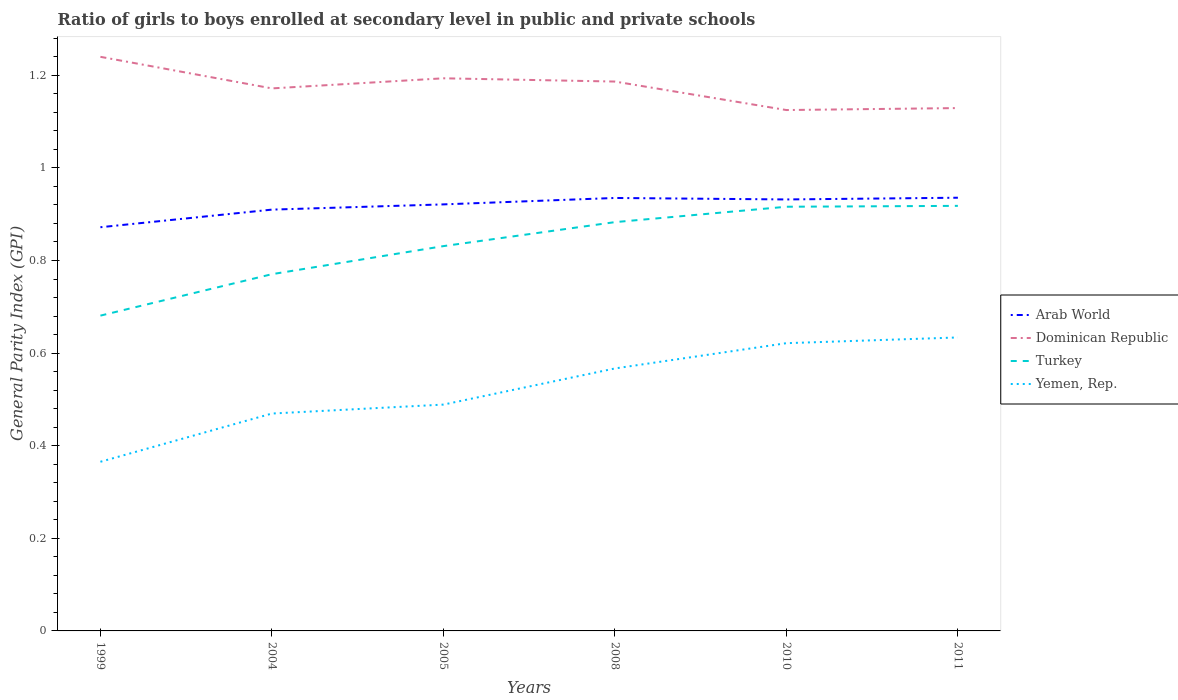How many different coloured lines are there?
Offer a terse response. 4. Across all years, what is the maximum general parity index in Turkey?
Make the answer very short. 0.68. In which year was the general parity index in Turkey maximum?
Ensure brevity in your answer.  1999. What is the total general parity index in Dominican Republic in the graph?
Your answer should be very brief. 0.11. What is the difference between the highest and the second highest general parity index in Dominican Republic?
Ensure brevity in your answer.  0.11. Is the general parity index in Turkey strictly greater than the general parity index in Yemen, Rep. over the years?
Give a very brief answer. No. What is the difference between two consecutive major ticks on the Y-axis?
Keep it short and to the point. 0.2. Does the graph contain any zero values?
Keep it short and to the point. No. Does the graph contain grids?
Your answer should be compact. No. Where does the legend appear in the graph?
Provide a succinct answer. Center right. How many legend labels are there?
Ensure brevity in your answer.  4. What is the title of the graph?
Make the answer very short. Ratio of girls to boys enrolled at secondary level in public and private schools. What is the label or title of the X-axis?
Your answer should be compact. Years. What is the label or title of the Y-axis?
Provide a short and direct response. General Parity Index (GPI). What is the General Parity Index (GPI) of Arab World in 1999?
Offer a terse response. 0.87. What is the General Parity Index (GPI) of Dominican Republic in 1999?
Provide a short and direct response. 1.24. What is the General Parity Index (GPI) in Turkey in 1999?
Offer a terse response. 0.68. What is the General Parity Index (GPI) of Yemen, Rep. in 1999?
Provide a short and direct response. 0.37. What is the General Parity Index (GPI) of Arab World in 2004?
Your response must be concise. 0.91. What is the General Parity Index (GPI) in Dominican Republic in 2004?
Keep it short and to the point. 1.17. What is the General Parity Index (GPI) of Turkey in 2004?
Your answer should be very brief. 0.77. What is the General Parity Index (GPI) of Yemen, Rep. in 2004?
Your answer should be very brief. 0.47. What is the General Parity Index (GPI) of Arab World in 2005?
Provide a short and direct response. 0.92. What is the General Parity Index (GPI) in Dominican Republic in 2005?
Make the answer very short. 1.19. What is the General Parity Index (GPI) in Turkey in 2005?
Your response must be concise. 0.83. What is the General Parity Index (GPI) in Yemen, Rep. in 2005?
Your answer should be compact. 0.49. What is the General Parity Index (GPI) in Arab World in 2008?
Ensure brevity in your answer.  0.94. What is the General Parity Index (GPI) in Dominican Republic in 2008?
Give a very brief answer. 1.19. What is the General Parity Index (GPI) in Turkey in 2008?
Offer a terse response. 0.88. What is the General Parity Index (GPI) in Yemen, Rep. in 2008?
Give a very brief answer. 0.57. What is the General Parity Index (GPI) of Arab World in 2010?
Your response must be concise. 0.93. What is the General Parity Index (GPI) of Dominican Republic in 2010?
Your answer should be very brief. 1.12. What is the General Parity Index (GPI) of Turkey in 2010?
Give a very brief answer. 0.92. What is the General Parity Index (GPI) of Yemen, Rep. in 2010?
Your response must be concise. 0.62. What is the General Parity Index (GPI) of Arab World in 2011?
Offer a terse response. 0.94. What is the General Parity Index (GPI) of Dominican Republic in 2011?
Make the answer very short. 1.13. What is the General Parity Index (GPI) of Turkey in 2011?
Your answer should be very brief. 0.92. What is the General Parity Index (GPI) of Yemen, Rep. in 2011?
Offer a terse response. 0.63. Across all years, what is the maximum General Parity Index (GPI) of Arab World?
Keep it short and to the point. 0.94. Across all years, what is the maximum General Parity Index (GPI) of Dominican Republic?
Your answer should be very brief. 1.24. Across all years, what is the maximum General Parity Index (GPI) in Turkey?
Give a very brief answer. 0.92. Across all years, what is the maximum General Parity Index (GPI) of Yemen, Rep.?
Make the answer very short. 0.63. Across all years, what is the minimum General Parity Index (GPI) of Arab World?
Your response must be concise. 0.87. Across all years, what is the minimum General Parity Index (GPI) of Dominican Republic?
Keep it short and to the point. 1.12. Across all years, what is the minimum General Parity Index (GPI) of Turkey?
Your response must be concise. 0.68. Across all years, what is the minimum General Parity Index (GPI) in Yemen, Rep.?
Offer a very short reply. 0.37. What is the total General Parity Index (GPI) of Arab World in the graph?
Offer a very short reply. 5.51. What is the total General Parity Index (GPI) in Dominican Republic in the graph?
Offer a terse response. 7.05. What is the total General Parity Index (GPI) in Turkey in the graph?
Keep it short and to the point. 5. What is the total General Parity Index (GPI) in Yemen, Rep. in the graph?
Offer a very short reply. 3.15. What is the difference between the General Parity Index (GPI) in Arab World in 1999 and that in 2004?
Provide a succinct answer. -0.04. What is the difference between the General Parity Index (GPI) in Dominican Republic in 1999 and that in 2004?
Provide a short and direct response. 0.07. What is the difference between the General Parity Index (GPI) in Turkey in 1999 and that in 2004?
Provide a short and direct response. -0.09. What is the difference between the General Parity Index (GPI) in Yemen, Rep. in 1999 and that in 2004?
Your response must be concise. -0.1. What is the difference between the General Parity Index (GPI) in Arab World in 1999 and that in 2005?
Provide a short and direct response. -0.05. What is the difference between the General Parity Index (GPI) of Dominican Republic in 1999 and that in 2005?
Your answer should be compact. 0.05. What is the difference between the General Parity Index (GPI) in Turkey in 1999 and that in 2005?
Your answer should be compact. -0.15. What is the difference between the General Parity Index (GPI) in Yemen, Rep. in 1999 and that in 2005?
Your response must be concise. -0.12. What is the difference between the General Parity Index (GPI) in Arab World in 1999 and that in 2008?
Keep it short and to the point. -0.06. What is the difference between the General Parity Index (GPI) of Dominican Republic in 1999 and that in 2008?
Your answer should be very brief. 0.05. What is the difference between the General Parity Index (GPI) in Turkey in 1999 and that in 2008?
Ensure brevity in your answer.  -0.2. What is the difference between the General Parity Index (GPI) of Yemen, Rep. in 1999 and that in 2008?
Ensure brevity in your answer.  -0.2. What is the difference between the General Parity Index (GPI) of Arab World in 1999 and that in 2010?
Keep it short and to the point. -0.06. What is the difference between the General Parity Index (GPI) in Dominican Republic in 1999 and that in 2010?
Give a very brief answer. 0.11. What is the difference between the General Parity Index (GPI) in Turkey in 1999 and that in 2010?
Provide a succinct answer. -0.24. What is the difference between the General Parity Index (GPI) in Yemen, Rep. in 1999 and that in 2010?
Your answer should be very brief. -0.26. What is the difference between the General Parity Index (GPI) of Arab World in 1999 and that in 2011?
Keep it short and to the point. -0.06. What is the difference between the General Parity Index (GPI) in Dominican Republic in 1999 and that in 2011?
Provide a short and direct response. 0.11. What is the difference between the General Parity Index (GPI) in Turkey in 1999 and that in 2011?
Keep it short and to the point. -0.24. What is the difference between the General Parity Index (GPI) in Yemen, Rep. in 1999 and that in 2011?
Ensure brevity in your answer.  -0.27. What is the difference between the General Parity Index (GPI) in Arab World in 2004 and that in 2005?
Keep it short and to the point. -0.01. What is the difference between the General Parity Index (GPI) in Dominican Republic in 2004 and that in 2005?
Make the answer very short. -0.02. What is the difference between the General Parity Index (GPI) in Turkey in 2004 and that in 2005?
Make the answer very short. -0.06. What is the difference between the General Parity Index (GPI) in Yemen, Rep. in 2004 and that in 2005?
Make the answer very short. -0.02. What is the difference between the General Parity Index (GPI) in Arab World in 2004 and that in 2008?
Provide a succinct answer. -0.03. What is the difference between the General Parity Index (GPI) in Dominican Republic in 2004 and that in 2008?
Ensure brevity in your answer.  -0.01. What is the difference between the General Parity Index (GPI) of Turkey in 2004 and that in 2008?
Give a very brief answer. -0.11. What is the difference between the General Parity Index (GPI) in Yemen, Rep. in 2004 and that in 2008?
Your response must be concise. -0.1. What is the difference between the General Parity Index (GPI) in Arab World in 2004 and that in 2010?
Your answer should be compact. -0.02. What is the difference between the General Parity Index (GPI) in Dominican Republic in 2004 and that in 2010?
Provide a succinct answer. 0.05. What is the difference between the General Parity Index (GPI) of Turkey in 2004 and that in 2010?
Provide a succinct answer. -0.15. What is the difference between the General Parity Index (GPI) of Yemen, Rep. in 2004 and that in 2010?
Offer a terse response. -0.15. What is the difference between the General Parity Index (GPI) of Arab World in 2004 and that in 2011?
Your answer should be compact. -0.03. What is the difference between the General Parity Index (GPI) of Dominican Republic in 2004 and that in 2011?
Provide a short and direct response. 0.04. What is the difference between the General Parity Index (GPI) of Turkey in 2004 and that in 2011?
Make the answer very short. -0.15. What is the difference between the General Parity Index (GPI) of Yemen, Rep. in 2004 and that in 2011?
Give a very brief answer. -0.16. What is the difference between the General Parity Index (GPI) of Arab World in 2005 and that in 2008?
Your answer should be very brief. -0.01. What is the difference between the General Parity Index (GPI) in Dominican Republic in 2005 and that in 2008?
Offer a very short reply. 0.01. What is the difference between the General Parity Index (GPI) of Turkey in 2005 and that in 2008?
Offer a very short reply. -0.05. What is the difference between the General Parity Index (GPI) of Yemen, Rep. in 2005 and that in 2008?
Your answer should be very brief. -0.08. What is the difference between the General Parity Index (GPI) in Arab World in 2005 and that in 2010?
Give a very brief answer. -0.01. What is the difference between the General Parity Index (GPI) of Dominican Republic in 2005 and that in 2010?
Make the answer very short. 0.07. What is the difference between the General Parity Index (GPI) of Turkey in 2005 and that in 2010?
Keep it short and to the point. -0.09. What is the difference between the General Parity Index (GPI) in Yemen, Rep. in 2005 and that in 2010?
Give a very brief answer. -0.13. What is the difference between the General Parity Index (GPI) of Arab World in 2005 and that in 2011?
Offer a very short reply. -0.01. What is the difference between the General Parity Index (GPI) of Dominican Republic in 2005 and that in 2011?
Keep it short and to the point. 0.06. What is the difference between the General Parity Index (GPI) in Turkey in 2005 and that in 2011?
Provide a short and direct response. -0.09. What is the difference between the General Parity Index (GPI) in Yemen, Rep. in 2005 and that in 2011?
Offer a very short reply. -0.14. What is the difference between the General Parity Index (GPI) in Arab World in 2008 and that in 2010?
Your answer should be very brief. 0. What is the difference between the General Parity Index (GPI) of Dominican Republic in 2008 and that in 2010?
Your answer should be very brief. 0.06. What is the difference between the General Parity Index (GPI) in Turkey in 2008 and that in 2010?
Your response must be concise. -0.03. What is the difference between the General Parity Index (GPI) of Yemen, Rep. in 2008 and that in 2010?
Your response must be concise. -0.05. What is the difference between the General Parity Index (GPI) in Arab World in 2008 and that in 2011?
Your answer should be compact. -0. What is the difference between the General Parity Index (GPI) of Dominican Republic in 2008 and that in 2011?
Your answer should be very brief. 0.06. What is the difference between the General Parity Index (GPI) of Turkey in 2008 and that in 2011?
Your answer should be compact. -0.04. What is the difference between the General Parity Index (GPI) in Yemen, Rep. in 2008 and that in 2011?
Ensure brevity in your answer.  -0.07. What is the difference between the General Parity Index (GPI) in Arab World in 2010 and that in 2011?
Your response must be concise. -0. What is the difference between the General Parity Index (GPI) of Dominican Republic in 2010 and that in 2011?
Provide a succinct answer. -0. What is the difference between the General Parity Index (GPI) in Turkey in 2010 and that in 2011?
Ensure brevity in your answer.  -0. What is the difference between the General Parity Index (GPI) of Yemen, Rep. in 2010 and that in 2011?
Provide a succinct answer. -0.01. What is the difference between the General Parity Index (GPI) in Arab World in 1999 and the General Parity Index (GPI) in Dominican Republic in 2004?
Your answer should be very brief. -0.3. What is the difference between the General Parity Index (GPI) in Arab World in 1999 and the General Parity Index (GPI) in Turkey in 2004?
Offer a very short reply. 0.1. What is the difference between the General Parity Index (GPI) in Arab World in 1999 and the General Parity Index (GPI) in Yemen, Rep. in 2004?
Provide a succinct answer. 0.4. What is the difference between the General Parity Index (GPI) in Dominican Republic in 1999 and the General Parity Index (GPI) in Turkey in 2004?
Provide a short and direct response. 0.47. What is the difference between the General Parity Index (GPI) of Dominican Republic in 1999 and the General Parity Index (GPI) of Yemen, Rep. in 2004?
Ensure brevity in your answer.  0.77. What is the difference between the General Parity Index (GPI) in Turkey in 1999 and the General Parity Index (GPI) in Yemen, Rep. in 2004?
Your answer should be very brief. 0.21. What is the difference between the General Parity Index (GPI) in Arab World in 1999 and the General Parity Index (GPI) in Dominican Republic in 2005?
Provide a succinct answer. -0.32. What is the difference between the General Parity Index (GPI) of Arab World in 1999 and the General Parity Index (GPI) of Turkey in 2005?
Offer a terse response. 0.04. What is the difference between the General Parity Index (GPI) in Arab World in 1999 and the General Parity Index (GPI) in Yemen, Rep. in 2005?
Your answer should be very brief. 0.38. What is the difference between the General Parity Index (GPI) of Dominican Republic in 1999 and the General Parity Index (GPI) of Turkey in 2005?
Give a very brief answer. 0.41. What is the difference between the General Parity Index (GPI) of Dominican Republic in 1999 and the General Parity Index (GPI) of Yemen, Rep. in 2005?
Keep it short and to the point. 0.75. What is the difference between the General Parity Index (GPI) of Turkey in 1999 and the General Parity Index (GPI) of Yemen, Rep. in 2005?
Offer a very short reply. 0.19. What is the difference between the General Parity Index (GPI) in Arab World in 1999 and the General Parity Index (GPI) in Dominican Republic in 2008?
Your answer should be very brief. -0.31. What is the difference between the General Parity Index (GPI) in Arab World in 1999 and the General Parity Index (GPI) in Turkey in 2008?
Give a very brief answer. -0.01. What is the difference between the General Parity Index (GPI) in Arab World in 1999 and the General Parity Index (GPI) in Yemen, Rep. in 2008?
Offer a very short reply. 0.3. What is the difference between the General Parity Index (GPI) in Dominican Republic in 1999 and the General Parity Index (GPI) in Turkey in 2008?
Offer a very short reply. 0.36. What is the difference between the General Parity Index (GPI) of Dominican Republic in 1999 and the General Parity Index (GPI) of Yemen, Rep. in 2008?
Keep it short and to the point. 0.67. What is the difference between the General Parity Index (GPI) in Turkey in 1999 and the General Parity Index (GPI) in Yemen, Rep. in 2008?
Give a very brief answer. 0.11. What is the difference between the General Parity Index (GPI) in Arab World in 1999 and the General Parity Index (GPI) in Dominican Republic in 2010?
Make the answer very short. -0.25. What is the difference between the General Parity Index (GPI) of Arab World in 1999 and the General Parity Index (GPI) of Turkey in 2010?
Your response must be concise. -0.04. What is the difference between the General Parity Index (GPI) in Arab World in 1999 and the General Parity Index (GPI) in Yemen, Rep. in 2010?
Provide a succinct answer. 0.25. What is the difference between the General Parity Index (GPI) in Dominican Republic in 1999 and the General Parity Index (GPI) in Turkey in 2010?
Offer a terse response. 0.32. What is the difference between the General Parity Index (GPI) in Dominican Republic in 1999 and the General Parity Index (GPI) in Yemen, Rep. in 2010?
Your answer should be compact. 0.62. What is the difference between the General Parity Index (GPI) of Turkey in 1999 and the General Parity Index (GPI) of Yemen, Rep. in 2010?
Offer a very short reply. 0.06. What is the difference between the General Parity Index (GPI) in Arab World in 1999 and the General Parity Index (GPI) in Dominican Republic in 2011?
Keep it short and to the point. -0.26. What is the difference between the General Parity Index (GPI) in Arab World in 1999 and the General Parity Index (GPI) in Turkey in 2011?
Ensure brevity in your answer.  -0.05. What is the difference between the General Parity Index (GPI) of Arab World in 1999 and the General Parity Index (GPI) of Yemen, Rep. in 2011?
Your response must be concise. 0.24. What is the difference between the General Parity Index (GPI) in Dominican Republic in 1999 and the General Parity Index (GPI) in Turkey in 2011?
Ensure brevity in your answer.  0.32. What is the difference between the General Parity Index (GPI) in Dominican Republic in 1999 and the General Parity Index (GPI) in Yemen, Rep. in 2011?
Provide a succinct answer. 0.61. What is the difference between the General Parity Index (GPI) of Turkey in 1999 and the General Parity Index (GPI) of Yemen, Rep. in 2011?
Provide a short and direct response. 0.05. What is the difference between the General Parity Index (GPI) in Arab World in 2004 and the General Parity Index (GPI) in Dominican Republic in 2005?
Offer a terse response. -0.28. What is the difference between the General Parity Index (GPI) of Arab World in 2004 and the General Parity Index (GPI) of Turkey in 2005?
Your response must be concise. 0.08. What is the difference between the General Parity Index (GPI) of Arab World in 2004 and the General Parity Index (GPI) of Yemen, Rep. in 2005?
Provide a succinct answer. 0.42. What is the difference between the General Parity Index (GPI) in Dominican Republic in 2004 and the General Parity Index (GPI) in Turkey in 2005?
Offer a terse response. 0.34. What is the difference between the General Parity Index (GPI) in Dominican Republic in 2004 and the General Parity Index (GPI) in Yemen, Rep. in 2005?
Keep it short and to the point. 0.68. What is the difference between the General Parity Index (GPI) of Turkey in 2004 and the General Parity Index (GPI) of Yemen, Rep. in 2005?
Keep it short and to the point. 0.28. What is the difference between the General Parity Index (GPI) in Arab World in 2004 and the General Parity Index (GPI) in Dominican Republic in 2008?
Make the answer very short. -0.28. What is the difference between the General Parity Index (GPI) in Arab World in 2004 and the General Parity Index (GPI) in Turkey in 2008?
Give a very brief answer. 0.03. What is the difference between the General Parity Index (GPI) of Arab World in 2004 and the General Parity Index (GPI) of Yemen, Rep. in 2008?
Ensure brevity in your answer.  0.34. What is the difference between the General Parity Index (GPI) of Dominican Republic in 2004 and the General Parity Index (GPI) of Turkey in 2008?
Offer a terse response. 0.29. What is the difference between the General Parity Index (GPI) in Dominican Republic in 2004 and the General Parity Index (GPI) in Yemen, Rep. in 2008?
Your response must be concise. 0.6. What is the difference between the General Parity Index (GPI) in Turkey in 2004 and the General Parity Index (GPI) in Yemen, Rep. in 2008?
Ensure brevity in your answer.  0.2. What is the difference between the General Parity Index (GPI) of Arab World in 2004 and the General Parity Index (GPI) of Dominican Republic in 2010?
Give a very brief answer. -0.22. What is the difference between the General Parity Index (GPI) in Arab World in 2004 and the General Parity Index (GPI) in Turkey in 2010?
Offer a terse response. -0.01. What is the difference between the General Parity Index (GPI) of Arab World in 2004 and the General Parity Index (GPI) of Yemen, Rep. in 2010?
Offer a terse response. 0.29. What is the difference between the General Parity Index (GPI) of Dominican Republic in 2004 and the General Parity Index (GPI) of Turkey in 2010?
Ensure brevity in your answer.  0.26. What is the difference between the General Parity Index (GPI) in Dominican Republic in 2004 and the General Parity Index (GPI) in Yemen, Rep. in 2010?
Offer a very short reply. 0.55. What is the difference between the General Parity Index (GPI) in Turkey in 2004 and the General Parity Index (GPI) in Yemen, Rep. in 2010?
Provide a short and direct response. 0.15. What is the difference between the General Parity Index (GPI) of Arab World in 2004 and the General Parity Index (GPI) of Dominican Republic in 2011?
Provide a short and direct response. -0.22. What is the difference between the General Parity Index (GPI) in Arab World in 2004 and the General Parity Index (GPI) in Turkey in 2011?
Give a very brief answer. -0.01. What is the difference between the General Parity Index (GPI) of Arab World in 2004 and the General Parity Index (GPI) of Yemen, Rep. in 2011?
Keep it short and to the point. 0.28. What is the difference between the General Parity Index (GPI) of Dominican Republic in 2004 and the General Parity Index (GPI) of Turkey in 2011?
Keep it short and to the point. 0.25. What is the difference between the General Parity Index (GPI) in Dominican Republic in 2004 and the General Parity Index (GPI) in Yemen, Rep. in 2011?
Offer a terse response. 0.54. What is the difference between the General Parity Index (GPI) in Turkey in 2004 and the General Parity Index (GPI) in Yemen, Rep. in 2011?
Offer a very short reply. 0.14. What is the difference between the General Parity Index (GPI) of Arab World in 2005 and the General Parity Index (GPI) of Dominican Republic in 2008?
Keep it short and to the point. -0.27. What is the difference between the General Parity Index (GPI) in Arab World in 2005 and the General Parity Index (GPI) in Turkey in 2008?
Make the answer very short. 0.04. What is the difference between the General Parity Index (GPI) of Arab World in 2005 and the General Parity Index (GPI) of Yemen, Rep. in 2008?
Your answer should be compact. 0.35. What is the difference between the General Parity Index (GPI) of Dominican Republic in 2005 and the General Parity Index (GPI) of Turkey in 2008?
Keep it short and to the point. 0.31. What is the difference between the General Parity Index (GPI) of Dominican Republic in 2005 and the General Parity Index (GPI) of Yemen, Rep. in 2008?
Provide a short and direct response. 0.63. What is the difference between the General Parity Index (GPI) of Turkey in 2005 and the General Parity Index (GPI) of Yemen, Rep. in 2008?
Offer a terse response. 0.26. What is the difference between the General Parity Index (GPI) of Arab World in 2005 and the General Parity Index (GPI) of Dominican Republic in 2010?
Offer a very short reply. -0.2. What is the difference between the General Parity Index (GPI) of Arab World in 2005 and the General Parity Index (GPI) of Turkey in 2010?
Your answer should be very brief. 0.01. What is the difference between the General Parity Index (GPI) of Arab World in 2005 and the General Parity Index (GPI) of Yemen, Rep. in 2010?
Your response must be concise. 0.3. What is the difference between the General Parity Index (GPI) in Dominican Republic in 2005 and the General Parity Index (GPI) in Turkey in 2010?
Give a very brief answer. 0.28. What is the difference between the General Parity Index (GPI) in Dominican Republic in 2005 and the General Parity Index (GPI) in Yemen, Rep. in 2010?
Your answer should be compact. 0.57. What is the difference between the General Parity Index (GPI) of Turkey in 2005 and the General Parity Index (GPI) of Yemen, Rep. in 2010?
Provide a short and direct response. 0.21. What is the difference between the General Parity Index (GPI) of Arab World in 2005 and the General Parity Index (GPI) of Dominican Republic in 2011?
Your answer should be very brief. -0.21. What is the difference between the General Parity Index (GPI) of Arab World in 2005 and the General Parity Index (GPI) of Turkey in 2011?
Provide a short and direct response. 0. What is the difference between the General Parity Index (GPI) in Arab World in 2005 and the General Parity Index (GPI) in Yemen, Rep. in 2011?
Your answer should be very brief. 0.29. What is the difference between the General Parity Index (GPI) of Dominican Republic in 2005 and the General Parity Index (GPI) of Turkey in 2011?
Give a very brief answer. 0.28. What is the difference between the General Parity Index (GPI) in Dominican Republic in 2005 and the General Parity Index (GPI) in Yemen, Rep. in 2011?
Offer a terse response. 0.56. What is the difference between the General Parity Index (GPI) of Turkey in 2005 and the General Parity Index (GPI) of Yemen, Rep. in 2011?
Your answer should be very brief. 0.2. What is the difference between the General Parity Index (GPI) in Arab World in 2008 and the General Parity Index (GPI) in Dominican Republic in 2010?
Keep it short and to the point. -0.19. What is the difference between the General Parity Index (GPI) of Arab World in 2008 and the General Parity Index (GPI) of Turkey in 2010?
Your response must be concise. 0.02. What is the difference between the General Parity Index (GPI) in Arab World in 2008 and the General Parity Index (GPI) in Yemen, Rep. in 2010?
Make the answer very short. 0.31. What is the difference between the General Parity Index (GPI) of Dominican Republic in 2008 and the General Parity Index (GPI) of Turkey in 2010?
Give a very brief answer. 0.27. What is the difference between the General Parity Index (GPI) of Dominican Republic in 2008 and the General Parity Index (GPI) of Yemen, Rep. in 2010?
Offer a very short reply. 0.56. What is the difference between the General Parity Index (GPI) in Turkey in 2008 and the General Parity Index (GPI) in Yemen, Rep. in 2010?
Ensure brevity in your answer.  0.26. What is the difference between the General Parity Index (GPI) in Arab World in 2008 and the General Parity Index (GPI) in Dominican Republic in 2011?
Ensure brevity in your answer.  -0.19. What is the difference between the General Parity Index (GPI) in Arab World in 2008 and the General Parity Index (GPI) in Turkey in 2011?
Make the answer very short. 0.02. What is the difference between the General Parity Index (GPI) in Arab World in 2008 and the General Parity Index (GPI) in Yemen, Rep. in 2011?
Your answer should be compact. 0.3. What is the difference between the General Parity Index (GPI) in Dominican Republic in 2008 and the General Parity Index (GPI) in Turkey in 2011?
Your answer should be compact. 0.27. What is the difference between the General Parity Index (GPI) of Dominican Republic in 2008 and the General Parity Index (GPI) of Yemen, Rep. in 2011?
Provide a succinct answer. 0.55. What is the difference between the General Parity Index (GPI) of Turkey in 2008 and the General Parity Index (GPI) of Yemen, Rep. in 2011?
Provide a short and direct response. 0.25. What is the difference between the General Parity Index (GPI) in Arab World in 2010 and the General Parity Index (GPI) in Dominican Republic in 2011?
Provide a succinct answer. -0.2. What is the difference between the General Parity Index (GPI) in Arab World in 2010 and the General Parity Index (GPI) in Turkey in 2011?
Your answer should be compact. 0.01. What is the difference between the General Parity Index (GPI) of Arab World in 2010 and the General Parity Index (GPI) of Yemen, Rep. in 2011?
Give a very brief answer. 0.3. What is the difference between the General Parity Index (GPI) in Dominican Republic in 2010 and the General Parity Index (GPI) in Turkey in 2011?
Provide a succinct answer. 0.21. What is the difference between the General Parity Index (GPI) in Dominican Republic in 2010 and the General Parity Index (GPI) in Yemen, Rep. in 2011?
Ensure brevity in your answer.  0.49. What is the difference between the General Parity Index (GPI) in Turkey in 2010 and the General Parity Index (GPI) in Yemen, Rep. in 2011?
Your response must be concise. 0.28. What is the average General Parity Index (GPI) of Arab World per year?
Offer a terse response. 0.92. What is the average General Parity Index (GPI) in Dominican Republic per year?
Provide a short and direct response. 1.17. What is the average General Parity Index (GPI) in Turkey per year?
Your answer should be compact. 0.83. What is the average General Parity Index (GPI) of Yemen, Rep. per year?
Make the answer very short. 0.52. In the year 1999, what is the difference between the General Parity Index (GPI) in Arab World and General Parity Index (GPI) in Dominican Republic?
Ensure brevity in your answer.  -0.37. In the year 1999, what is the difference between the General Parity Index (GPI) of Arab World and General Parity Index (GPI) of Turkey?
Give a very brief answer. 0.19. In the year 1999, what is the difference between the General Parity Index (GPI) of Arab World and General Parity Index (GPI) of Yemen, Rep.?
Keep it short and to the point. 0.51. In the year 1999, what is the difference between the General Parity Index (GPI) in Dominican Republic and General Parity Index (GPI) in Turkey?
Provide a short and direct response. 0.56. In the year 1999, what is the difference between the General Parity Index (GPI) in Dominican Republic and General Parity Index (GPI) in Yemen, Rep.?
Give a very brief answer. 0.87. In the year 1999, what is the difference between the General Parity Index (GPI) of Turkey and General Parity Index (GPI) of Yemen, Rep.?
Your response must be concise. 0.32. In the year 2004, what is the difference between the General Parity Index (GPI) of Arab World and General Parity Index (GPI) of Dominican Republic?
Provide a short and direct response. -0.26. In the year 2004, what is the difference between the General Parity Index (GPI) of Arab World and General Parity Index (GPI) of Turkey?
Your answer should be compact. 0.14. In the year 2004, what is the difference between the General Parity Index (GPI) in Arab World and General Parity Index (GPI) in Yemen, Rep.?
Make the answer very short. 0.44. In the year 2004, what is the difference between the General Parity Index (GPI) in Dominican Republic and General Parity Index (GPI) in Turkey?
Your answer should be very brief. 0.4. In the year 2004, what is the difference between the General Parity Index (GPI) of Dominican Republic and General Parity Index (GPI) of Yemen, Rep.?
Your answer should be very brief. 0.7. In the year 2004, what is the difference between the General Parity Index (GPI) of Turkey and General Parity Index (GPI) of Yemen, Rep.?
Offer a very short reply. 0.3. In the year 2005, what is the difference between the General Parity Index (GPI) in Arab World and General Parity Index (GPI) in Dominican Republic?
Ensure brevity in your answer.  -0.27. In the year 2005, what is the difference between the General Parity Index (GPI) in Arab World and General Parity Index (GPI) in Turkey?
Your answer should be compact. 0.09. In the year 2005, what is the difference between the General Parity Index (GPI) in Arab World and General Parity Index (GPI) in Yemen, Rep.?
Provide a short and direct response. 0.43. In the year 2005, what is the difference between the General Parity Index (GPI) in Dominican Republic and General Parity Index (GPI) in Turkey?
Offer a very short reply. 0.36. In the year 2005, what is the difference between the General Parity Index (GPI) in Dominican Republic and General Parity Index (GPI) in Yemen, Rep.?
Make the answer very short. 0.7. In the year 2005, what is the difference between the General Parity Index (GPI) of Turkey and General Parity Index (GPI) of Yemen, Rep.?
Give a very brief answer. 0.34. In the year 2008, what is the difference between the General Parity Index (GPI) in Arab World and General Parity Index (GPI) in Dominican Republic?
Offer a very short reply. -0.25. In the year 2008, what is the difference between the General Parity Index (GPI) in Arab World and General Parity Index (GPI) in Turkey?
Your answer should be very brief. 0.05. In the year 2008, what is the difference between the General Parity Index (GPI) in Arab World and General Parity Index (GPI) in Yemen, Rep.?
Your response must be concise. 0.37. In the year 2008, what is the difference between the General Parity Index (GPI) of Dominican Republic and General Parity Index (GPI) of Turkey?
Offer a terse response. 0.3. In the year 2008, what is the difference between the General Parity Index (GPI) in Dominican Republic and General Parity Index (GPI) in Yemen, Rep.?
Your answer should be compact. 0.62. In the year 2008, what is the difference between the General Parity Index (GPI) in Turkey and General Parity Index (GPI) in Yemen, Rep.?
Provide a short and direct response. 0.32. In the year 2010, what is the difference between the General Parity Index (GPI) in Arab World and General Parity Index (GPI) in Dominican Republic?
Provide a succinct answer. -0.19. In the year 2010, what is the difference between the General Parity Index (GPI) in Arab World and General Parity Index (GPI) in Turkey?
Your answer should be very brief. 0.02. In the year 2010, what is the difference between the General Parity Index (GPI) of Arab World and General Parity Index (GPI) of Yemen, Rep.?
Provide a short and direct response. 0.31. In the year 2010, what is the difference between the General Parity Index (GPI) in Dominican Republic and General Parity Index (GPI) in Turkey?
Your answer should be very brief. 0.21. In the year 2010, what is the difference between the General Parity Index (GPI) in Dominican Republic and General Parity Index (GPI) in Yemen, Rep.?
Your answer should be very brief. 0.5. In the year 2010, what is the difference between the General Parity Index (GPI) in Turkey and General Parity Index (GPI) in Yemen, Rep.?
Offer a terse response. 0.29. In the year 2011, what is the difference between the General Parity Index (GPI) of Arab World and General Parity Index (GPI) of Dominican Republic?
Keep it short and to the point. -0.19. In the year 2011, what is the difference between the General Parity Index (GPI) in Arab World and General Parity Index (GPI) in Turkey?
Offer a very short reply. 0.02. In the year 2011, what is the difference between the General Parity Index (GPI) of Arab World and General Parity Index (GPI) of Yemen, Rep.?
Your answer should be compact. 0.3. In the year 2011, what is the difference between the General Parity Index (GPI) in Dominican Republic and General Parity Index (GPI) in Turkey?
Ensure brevity in your answer.  0.21. In the year 2011, what is the difference between the General Parity Index (GPI) in Dominican Republic and General Parity Index (GPI) in Yemen, Rep.?
Offer a terse response. 0.5. In the year 2011, what is the difference between the General Parity Index (GPI) of Turkey and General Parity Index (GPI) of Yemen, Rep.?
Offer a terse response. 0.28. What is the ratio of the General Parity Index (GPI) of Arab World in 1999 to that in 2004?
Your answer should be very brief. 0.96. What is the ratio of the General Parity Index (GPI) in Dominican Republic in 1999 to that in 2004?
Keep it short and to the point. 1.06. What is the ratio of the General Parity Index (GPI) in Turkey in 1999 to that in 2004?
Your answer should be very brief. 0.88. What is the ratio of the General Parity Index (GPI) of Yemen, Rep. in 1999 to that in 2004?
Ensure brevity in your answer.  0.78. What is the ratio of the General Parity Index (GPI) of Arab World in 1999 to that in 2005?
Offer a very short reply. 0.95. What is the ratio of the General Parity Index (GPI) of Dominican Republic in 1999 to that in 2005?
Offer a very short reply. 1.04. What is the ratio of the General Parity Index (GPI) in Turkey in 1999 to that in 2005?
Offer a terse response. 0.82. What is the ratio of the General Parity Index (GPI) of Yemen, Rep. in 1999 to that in 2005?
Ensure brevity in your answer.  0.75. What is the ratio of the General Parity Index (GPI) of Arab World in 1999 to that in 2008?
Ensure brevity in your answer.  0.93. What is the ratio of the General Parity Index (GPI) in Dominican Republic in 1999 to that in 2008?
Provide a succinct answer. 1.04. What is the ratio of the General Parity Index (GPI) of Turkey in 1999 to that in 2008?
Keep it short and to the point. 0.77. What is the ratio of the General Parity Index (GPI) in Yemen, Rep. in 1999 to that in 2008?
Provide a short and direct response. 0.64. What is the ratio of the General Parity Index (GPI) of Arab World in 1999 to that in 2010?
Offer a terse response. 0.94. What is the ratio of the General Parity Index (GPI) in Dominican Republic in 1999 to that in 2010?
Ensure brevity in your answer.  1.1. What is the ratio of the General Parity Index (GPI) of Turkey in 1999 to that in 2010?
Offer a very short reply. 0.74. What is the ratio of the General Parity Index (GPI) of Yemen, Rep. in 1999 to that in 2010?
Offer a very short reply. 0.59. What is the ratio of the General Parity Index (GPI) in Arab World in 1999 to that in 2011?
Give a very brief answer. 0.93. What is the ratio of the General Parity Index (GPI) of Dominican Republic in 1999 to that in 2011?
Make the answer very short. 1.1. What is the ratio of the General Parity Index (GPI) in Turkey in 1999 to that in 2011?
Your answer should be very brief. 0.74. What is the ratio of the General Parity Index (GPI) in Yemen, Rep. in 1999 to that in 2011?
Ensure brevity in your answer.  0.58. What is the ratio of the General Parity Index (GPI) in Dominican Republic in 2004 to that in 2005?
Give a very brief answer. 0.98. What is the ratio of the General Parity Index (GPI) of Turkey in 2004 to that in 2005?
Keep it short and to the point. 0.93. What is the ratio of the General Parity Index (GPI) of Yemen, Rep. in 2004 to that in 2005?
Give a very brief answer. 0.96. What is the ratio of the General Parity Index (GPI) of Arab World in 2004 to that in 2008?
Offer a very short reply. 0.97. What is the ratio of the General Parity Index (GPI) of Dominican Republic in 2004 to that in 2008?
Your response must be concise. 0.99. What is the ratio of the General Parity Index (GPI) of Turkey in 2004 to that in 2008?
Ensure brevity in your answer.  0.87. What is the ratio of the General Parity Index (GPI) of Yemen, Rep. in 2004 to that in 2008?
Provide a short and direct response. 0.83. What is the ratio of the General Parity Index (GPI) of Arab World in 2004 to that in 2010?
Your response must be concise. 0.98. What is the ratio of the General Parity Index (GPI) in Dominican Republic in 2004 to that in 2010?
Your response must be concise. 1.04. What is the ratio of the General Parity Index (GPI) of Turkey in 2004 to that in 2010?
Keep it short and to the point. 0.84. What is the ratio of the General Parity Index (GPI) of Yemen, Rep. in 2004 to that in 2010?
Provide a short and direct response. 0.76. What is the ratio of the General Parity Index (GPI) in Arab World in 2004 to that in 2011?
Provide a succinct answer. 0.97. What is the ratio of the General Parity Index (GPI) of Dominican Republic in 2004 to that in 2011?
Ensure brevity in your answer.  1.04. What is the ratio of the General Parity Index (GPI) in Turkey in 2004 to that in 2011?
Make the answer very short. 0.84. What is the ratio of the General Parity Index (GPI) of Yemen, Rep. in 2004 to that in 2011?
Your answer should be compact. 0.74. What is the ratio of the General Parity Index (GPI) of Arab World in 2005 to that in 2008?
Make the answer very short. 0.99. What is the ratio of the General Parity Index (GPI) of Dominican Republic in 2005 to that in 2008?
Offer a terse response. 1.01. What is the ratio of the General Parity Index (GPI) in Turkey in 2005 to that in 2008?
Your answer should be compact. 0.94. What is the ratio of the General Parity Index (GPI) in Yemen, Rep. in 2005 to that in 2008?
Ensure brevity in your answer.  0.86. What is the ratio of the General Parity Index (GPI) of Dominican Republic in 2005 to that in 2010?
Make the answer very short. 1.06. What is the ratio of the General Parity Index (GPI) in Turkey in 2005 to that in 2010?
Give a very brief answer. 0.91. What is the ratio of the General Parity Index (GPI) of Yemen, Rep. in 2005 to that in 2010?
Provide a succinct answer. 0.79. What is the ratio of the General Parity Index (GPI) in Arab World in 2005 to that in 2011?
Your response must be concise. 0.98. What is the ratio of the General Parity Index (GPI) of Dominican Republic in 2005 to that in 2011?
Provide a short and direct response. 1.06. What is the ratio of the General Parity Index (GPI) in Turkey in 2005 to that in 2011?
Ensure brevity in your answer.  0.91. What is the ratio of the General Parity Index (GPI) of Yemen, Rep. in 2005 to that in 2011?
Make the answer very short. 0.77. What is the ratio of the General Parity Index (GPI) of Arab World in 2008 to that in 2010?
Your answer should be compact. 1. What is the ratio of the General Parity Index (GPI) of Dominican Republic in 2008 to that in 2010?
Your answer should be compact. 1.05. What is the ratio of the General Parity Index (GPI) of Turkey in 2008 to that in 2010?
Make the answer very short. 0.96. What is the ratio of the General Parity Index (GPI) of Yemen, Rep. in 2008 to that in 2010?
Ensure brevity in your answer.  0.91. What is the ratio of the General Parity Index (GPI) of Arab World in 2008 to that in 2011?
Ensure brevity in your answer.  1. What is the ratio of the General Parity Index (GPI) in Dominican Republic in 2008 to that in 2011?
Keep it short and to the point. 1.05. What is the ratio of the General Parity Index (GPI) of Turkey in 2008 to that in 2011?
Give a very brief answer. 0.96. What is the ratio of the General Parity Index (GPI) of Yemen, Rep. in 2008 to that in 2011?
Your answer should be very brief. 0.89. What is the ratio of the General Parity Index (GPI) in Dominican Republic in 2010 to that in 2011?
Keep it short and to the point. 1. What is the ratio of the General Parity Index (GPI) of Yemen, Rep. in 2010 to that in 2011?
Keep it short and to the point. 0.98. What is the difference between the highest and the second highest General Parity Index (GPI) of Arab World?
Your answer should be compact. 0. What is the difference between the highest and the second highest General Parity Index (GPI) of Dominican Republic?
Ensure brevity in your answer.  0.05. What is the difference between the highest and the second highest General Parity Index (GPI) of Turkey?
Keep it short and to the point. 0. What is the difference between the highest and the second highest General Parity Index (GPI) in Yemen, Rep.?
Provide a short and direct response. 0.01. What is the difference between the highest and the lowest General Parity Index (GPI) of Arab World?
Provide a short and direct response. 0.06. What is the difference between the highest and the lowest General Parity Index (GPI) of Dominican Republic?
Give a very brief answer. 0.11. What is the difference between the highest and the lowest General Parity Index (GPI) in Turkey?
Your answer should be very brief. 0.24. What is the difference between the highest and the lowest General Parity Index (GPI) in Yemen, Rep.?
Provide a short and direct response. 0.27. 